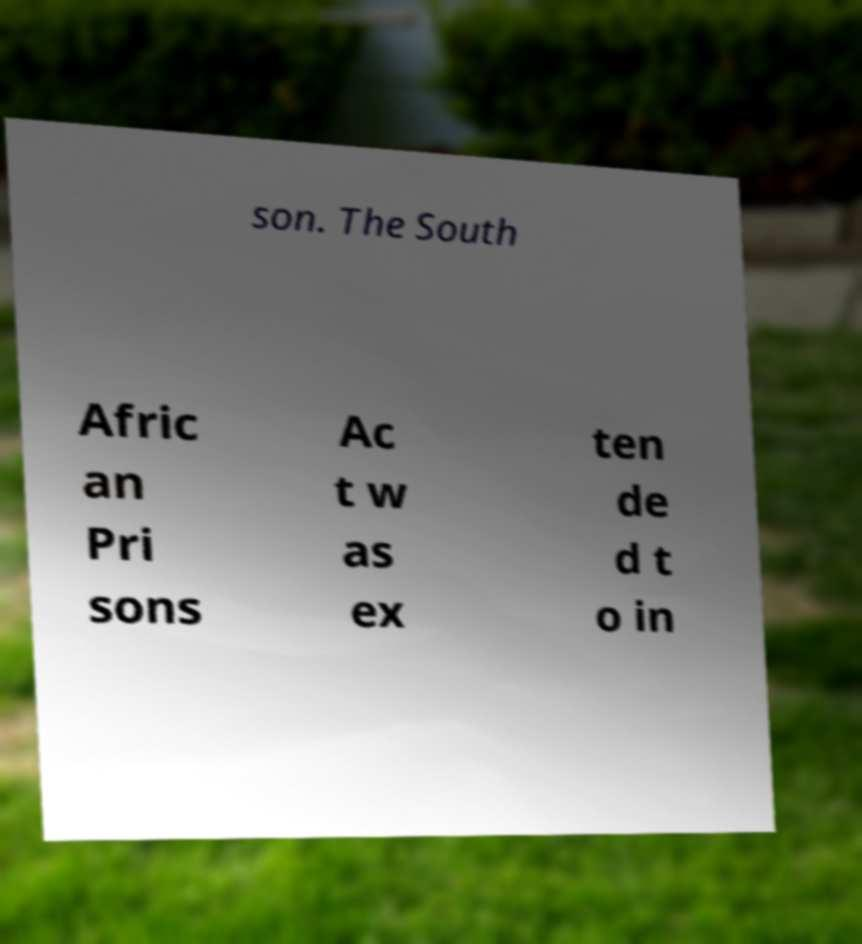Could you assist in decoding the text presented in this image and type it out clearly? son. The South Afric an Pri sons Ac t w as ex ten de d t o in 